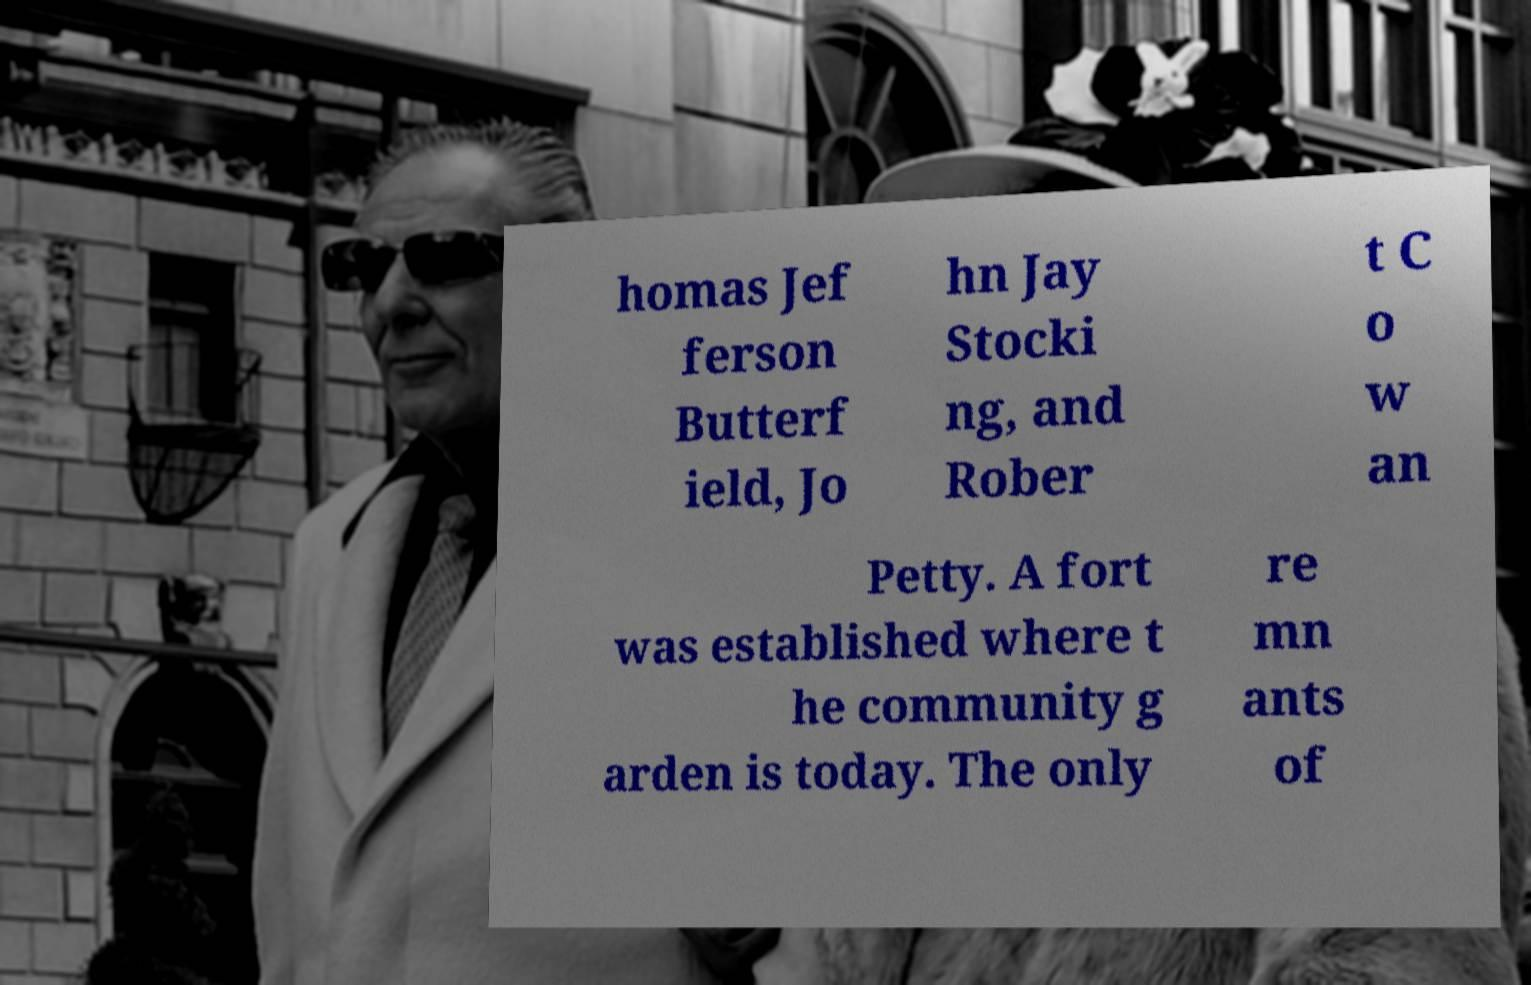Could you extract and type out the text from this image? homas Jef ferson Butterf ield, Jo hn Jay Stocki ng, and Rober t C o w an Petty. A fort was established where t he community g arden is today. The only re mn ants of 